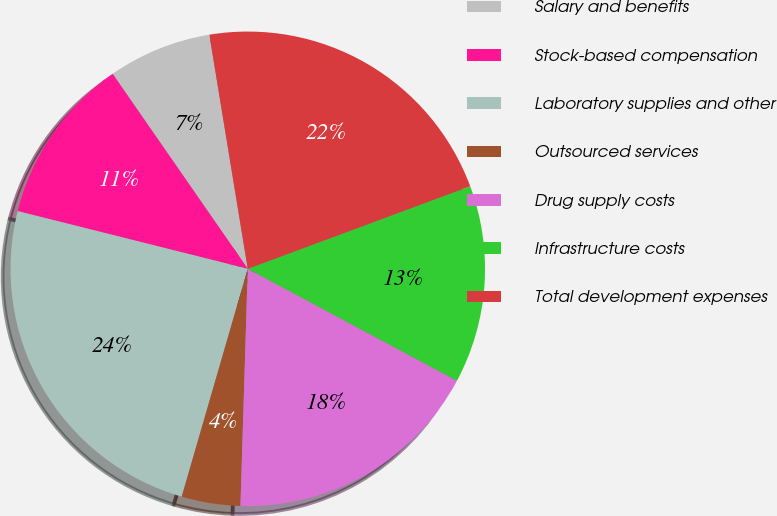Convert chart to OTSL. <chart><loc_0><loc_0><loc_500><loc_500><pie_chart><fcel>Salary and benefits<fcel>Stock-based compensation<fcel>Laboratory supplies and other<fcel>Outsourced services<fcel>Drug supply costs<fcel>Infrastructure costs<fcel>Total development expenses<nl><fcel>7.06%<fcel>11.44%<fcel>24.42%<fcel>4.0%<fcel>17.67%<fcel>13.48%<fcel>21.93%<nl></chart> 